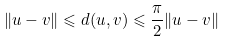<formula> <loc_0><loc_0><loc_500><loc_500>\| u - v \| \leqslant d ( u , v ) \leqslant \frac { \pi } { 2 } \| u - v \|</formula> 